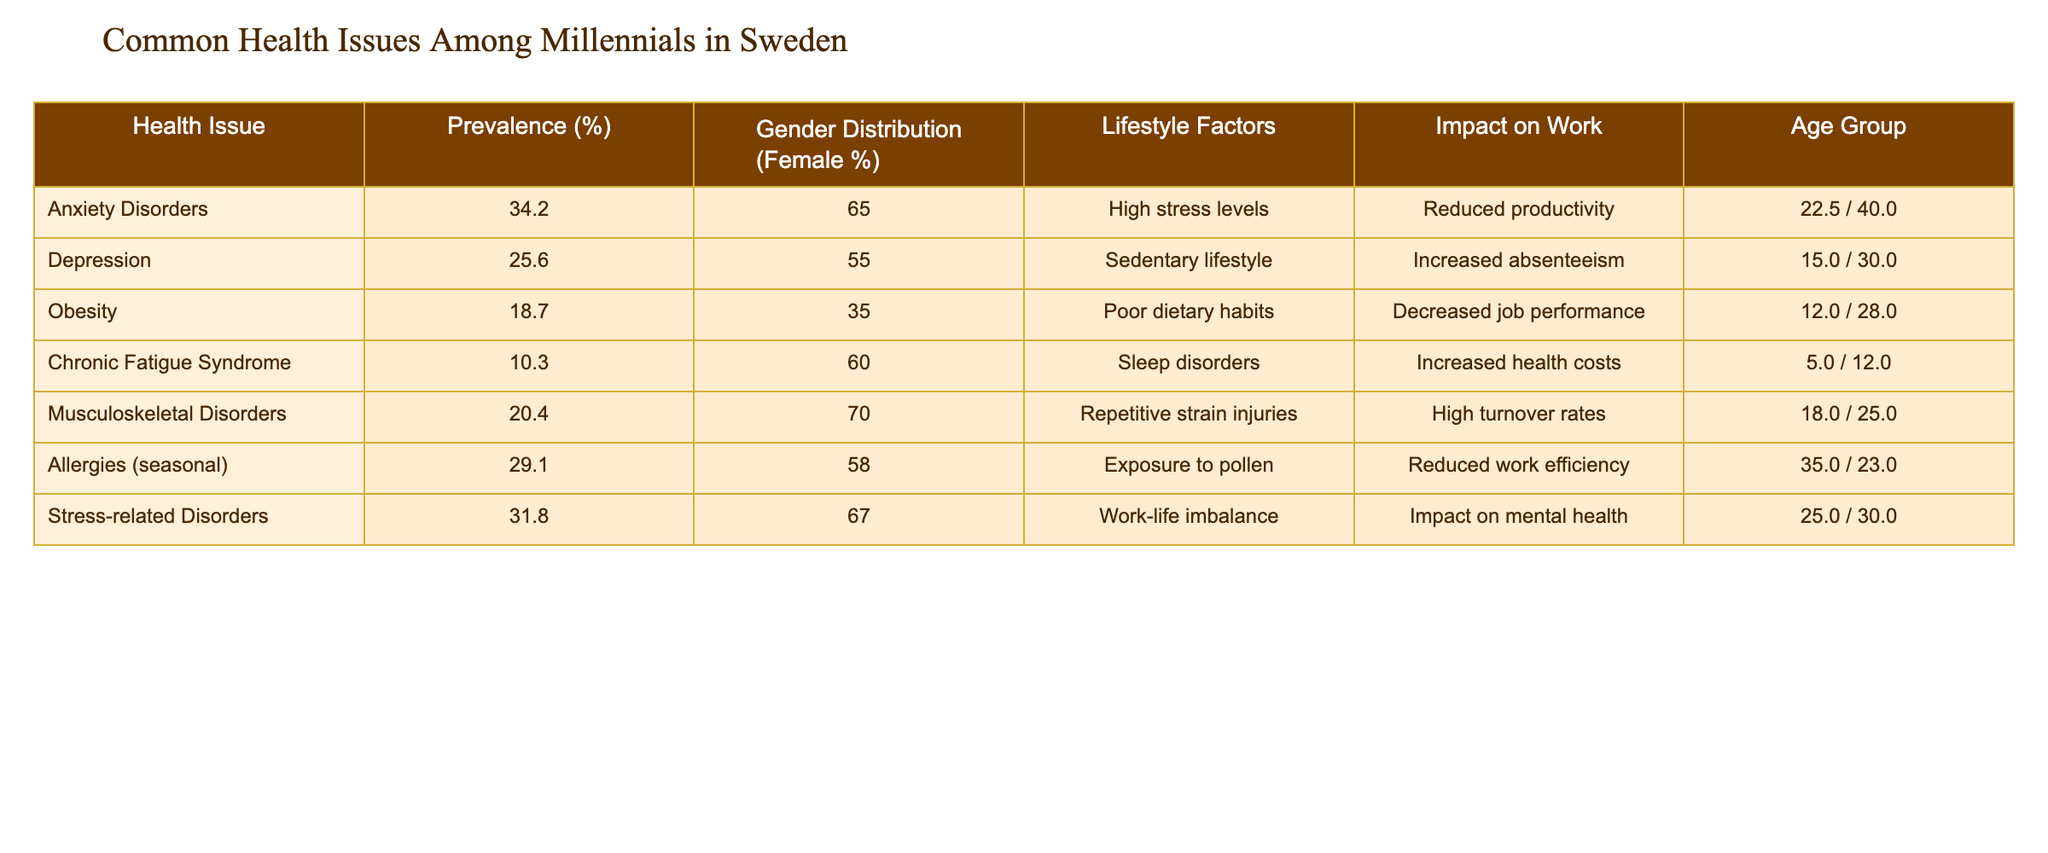What is the prevalence of anxiety disorders among millennials in Sweden? The table specifies the prevalence of anxiety disorders as 34.2%. This value is directly reported in the table without needing any calculations.
Answer: 34.2% Which age group has the highest prevalence of depression? From the table, the age group 25-34 has a prevalence of 30.0%, which is higher compared to the 15.0% in the 18-24 age group, indicating that 25-34 is the highest.
Answer: 25-34 What percentage of females are affected by musculoskeletal disorders? The table states that 70.0% of individuals affected by musculoskeletal disorders are female, which can be directly found in the Gender Distribution column.
Answer: 70.0% Does the prevalence of obesity exceed 20% among Swedish millennials? The table lists the prevalence of obesity as 18.7%, which is less than 20%, making the statement false.
Answer: No What is the average prevalence of stress-related disorders and anxiety disorders combined? The prevalence of stress-related disorders is 31.8% and anxiety disorders is 34.2%. Combining these gives 31.8 + 34.2 = 66.0. To find the average, divide by two: 66.0 / 2 = 33.0.
Answer: 33.0 Which lifestyle factor is associated with the highest impact on work according to the table? The table lists "High turnover rates" related to musculoskeletal disorders as the higher impact on work, making this factor significant among those listed.
Answer: High turnover rates Is it true that chronic fatigue syndrome has a lower prevalence than obesity among millennials in Sweden? The prevalence of chronic fatigue syndrome is reported as 10.3%, while obesity is at 18.7%. Since 10.3% is indeed lower than 18.7%, the statement is true.
Answer: Yes What percentage of millennials with allergies are in the age group 18-24? The table specifies 35.0% for the age group 18-24 affected by seasonal allergies, which can be found in the corresponding row.
Answer: 35.0% Which health issue has the lowest prevalence among the surveyed millennials? By comparing the prevalence rates listed in the table, chronic fatigue syndrome has the lowest value at 10.3%. Thus, it is the health issue with the lowest prevalence.
Answer: Chronic Fatigue Syndrome 